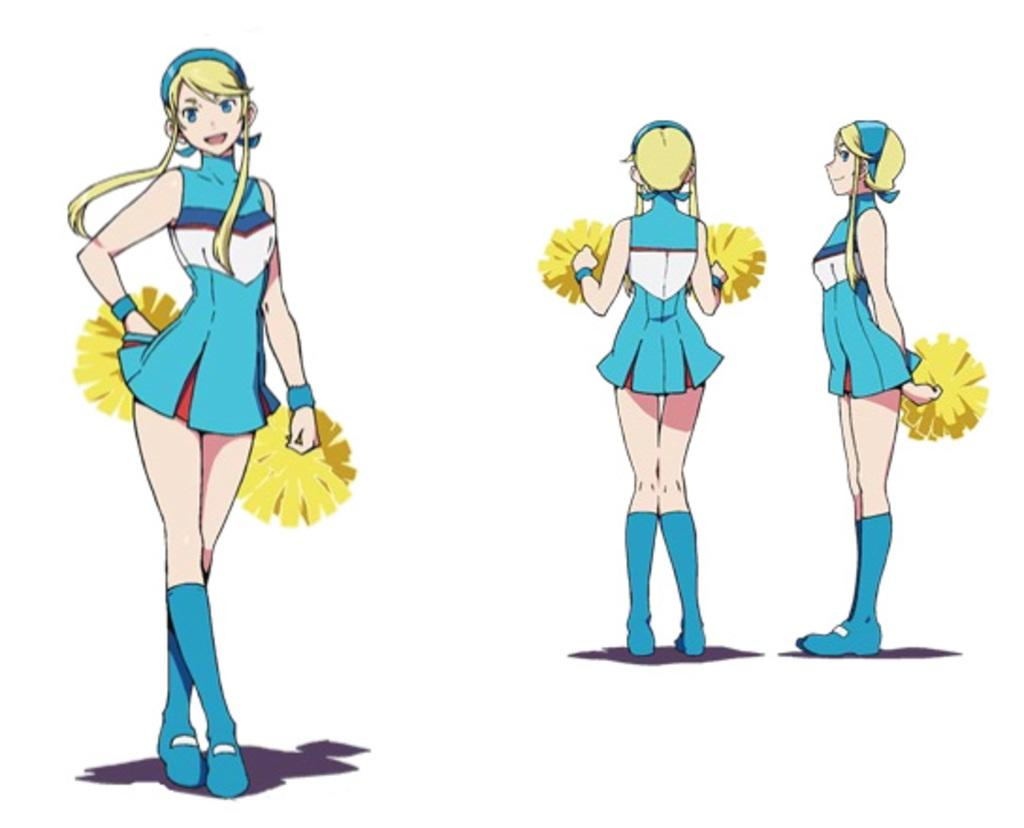What type of image is being described? The image is animated. How many persons are present in the image? There are three persons in the image. What are the persons doing in the image? The persons are standing in the image. What are the persons holding in the image? The persons are holding objects in the image. What color is the background of the image? The background of the image is white. How many zebras are visible in the image? There are no zebras present in the image. What type of ticket can be seen in the hands of the persons? There is no ticket visible in the image; the persons are holding objects, but their nature is not specified. 